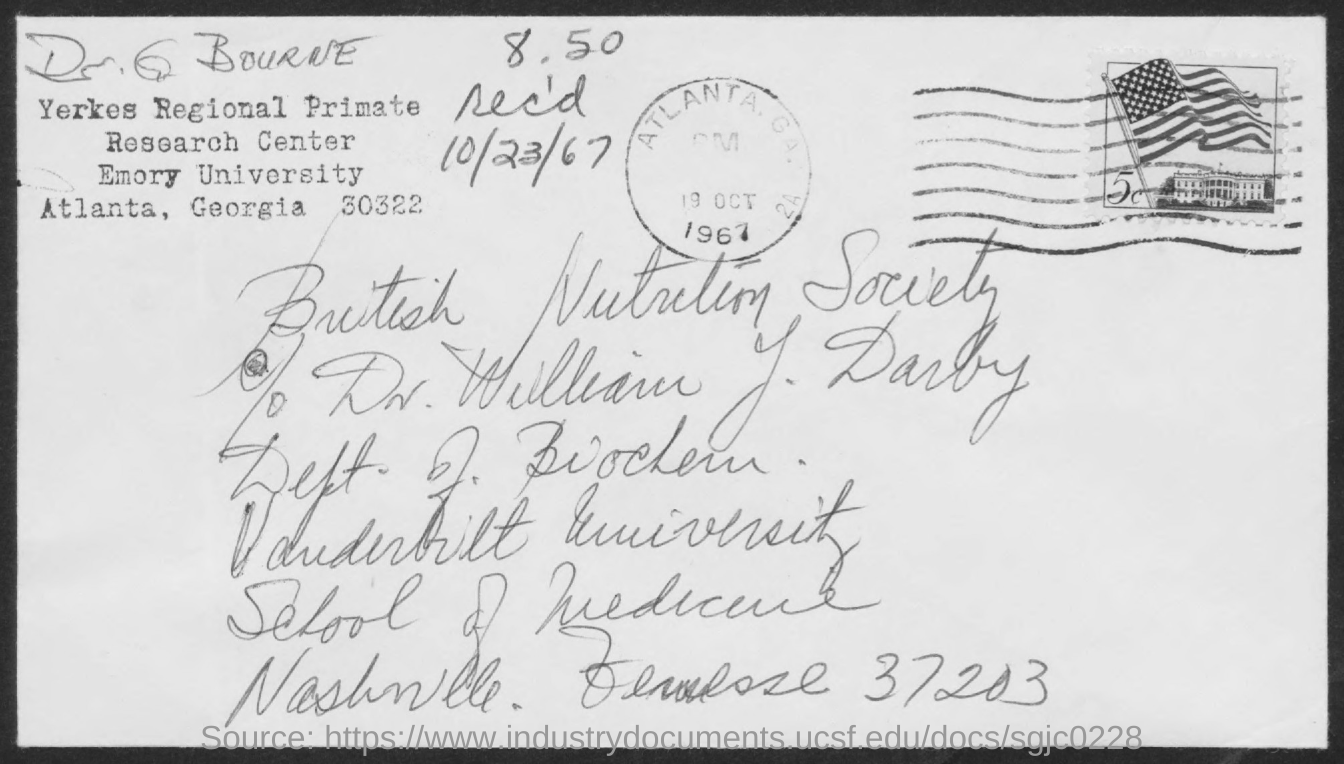What is the received date mentioned in the postal card?
Give a very brief answer. 10/23/67. 